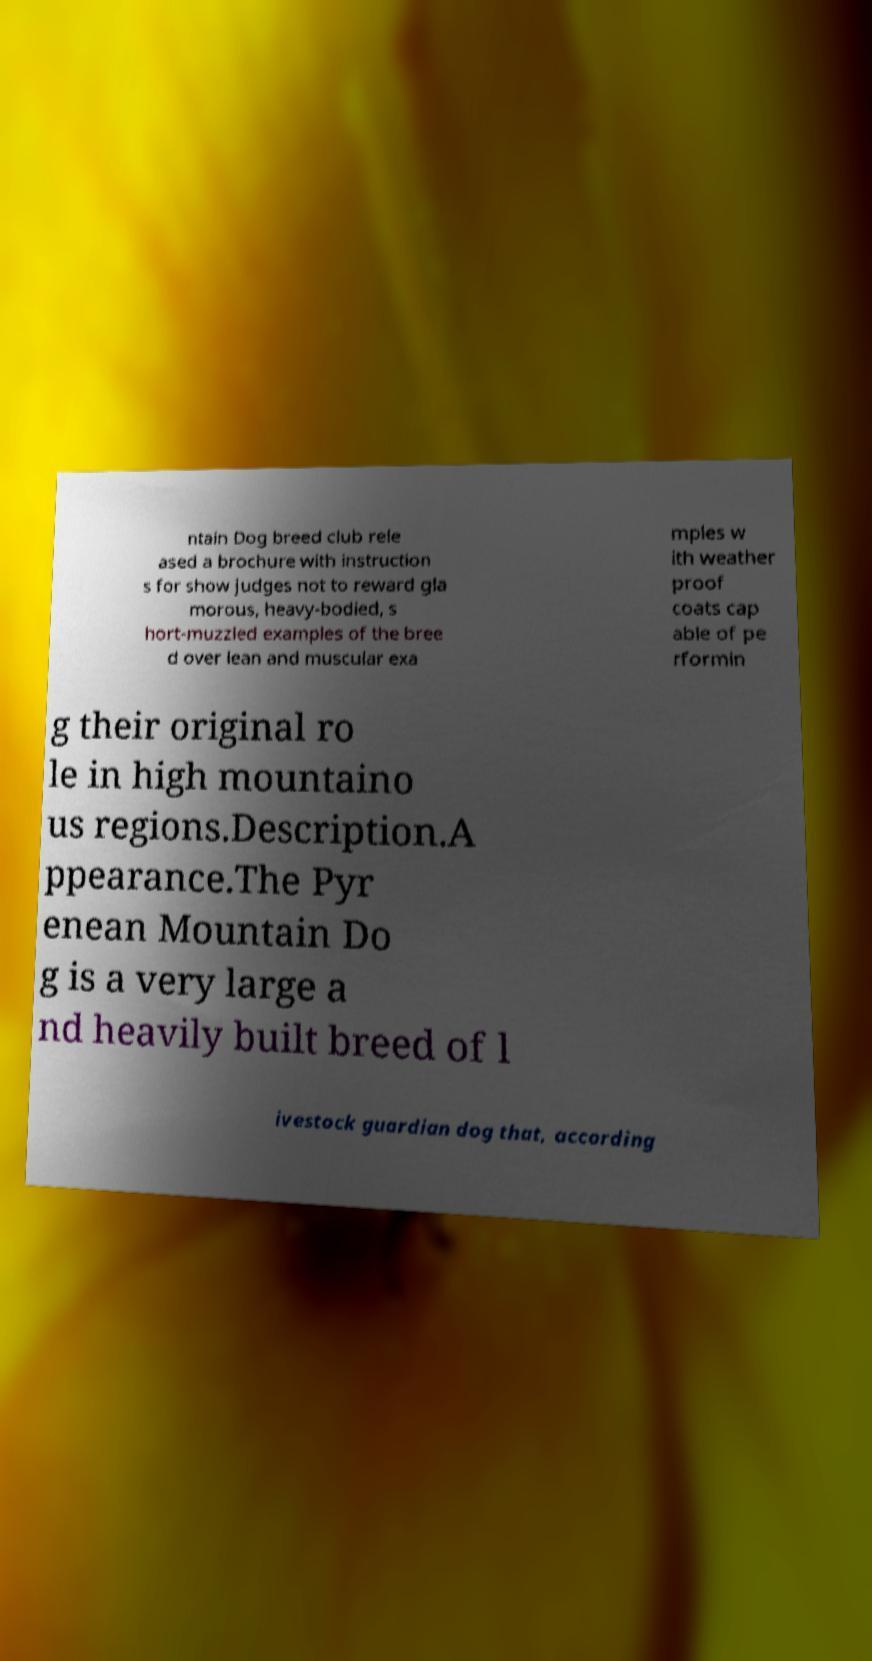Can you accurately transcribe the text from the provided image for me? ntain Dog breed club rele ased a brochure with instruction s for show judges not to reward gla morous, heavy-bodied, s hort-muzzled examples of the bree d over lean and muscular exa mples w ith weather proof coats cap able of pe rformin g their original ro le in high mountaino us regions.Description.A ppearance.The Pyr enean Mountain Do g is a very large a nd heavily built breed of l ivestock guardian dog that, according 